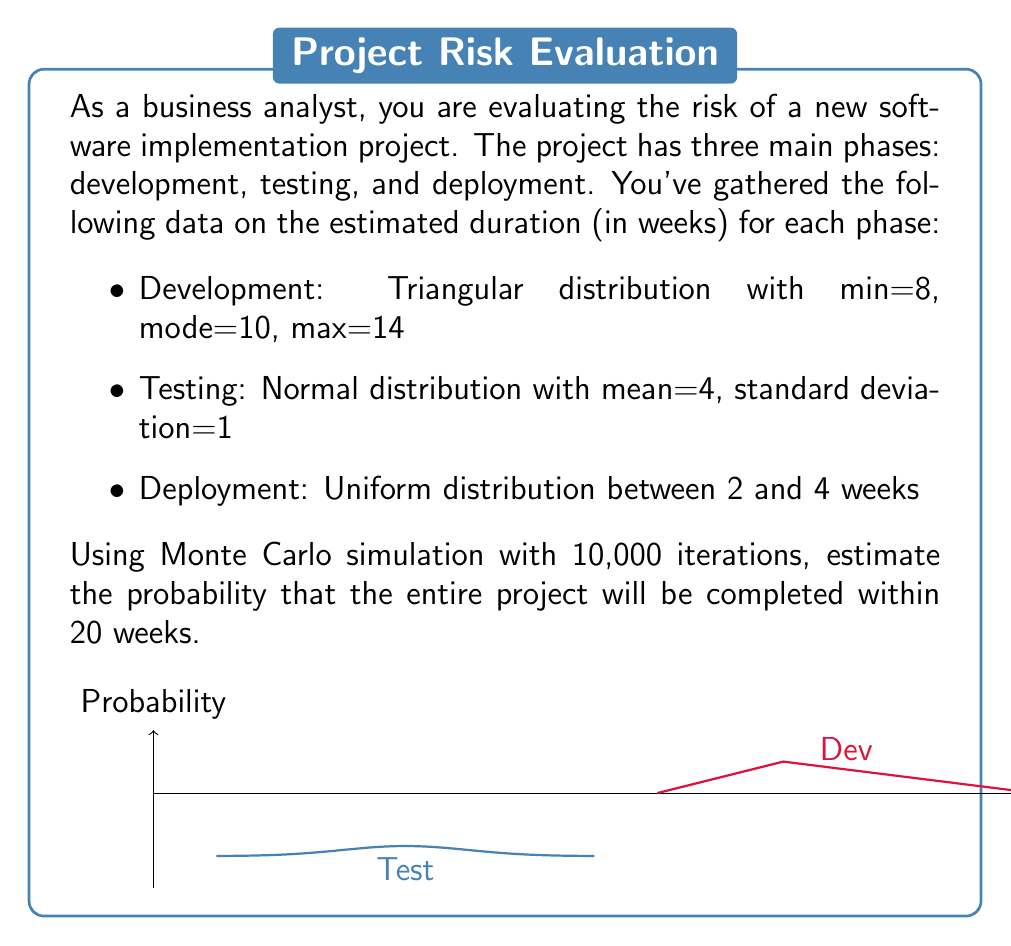Help me with this question. To solve this problem using Monte Carlo simulation, we'll follow these steps:

1) Set up the simulation:
   - Create a function for each distribution
   - Run 10,000 iterations
   - For each iteration, sample from each distribution and sum the results
   - Count how many times the sum is less than or equal to 20 weeks

2) Triangular distribution function:
   $$f(x) = \begin{cases}
   \frac{2(x-a)}{(b-a)(c-a)} & \text{for } a \leq x < c \\
   \frac{2(b-x)}{(b-a)(b-c)} & \text{for } c \leq x \leq b
   \end{cases}$$
   where $a=8$, $b=14$, and $c=10$

3) Normal distribution function:
   $$f(x) = \frac{1}{\sigma\sqrt{2\pi}} e^{-\frac{1}{2}(\frac{x-\mu}{\sigma})^2}$$
   where $\mu=4$ and $\sigma=1$

4) Uniform distribution function:
   $$f(x) = \frac{1}{b-a}$$
   where $a=2$ and $b=4$

5) Python code for the simulation:

```python
import numpy as np

def triangular(a, b, c):
    u = np.random.uniform(0, 1)
    if u < (c-a)/(b-a):
        return a + np.sqrt(u*(b-a)*(c-a))
    else:
        return b - np.sqrt((1-u)*(b-a)*(b-c))

iterations = 10000
count = 0

for _ in range(iterations):
    dev = triangular(8, 14, 10)
    test = np.random.normal(4, 1)
    deploy = np.random.uniform(2, 4)
    total = dev + test + deploy
    if total <= 20:
        count += 1

probability = count / iterations
```

6) After running the simulation, we calculate the probability:
   $$\text{Probability} = \frac{\text{Count of iterations } \leq 20 \text{ weeks}}{\text{Total iterations}}$$
Answer: $\approx 0.7265$ (or about 72.65%) 